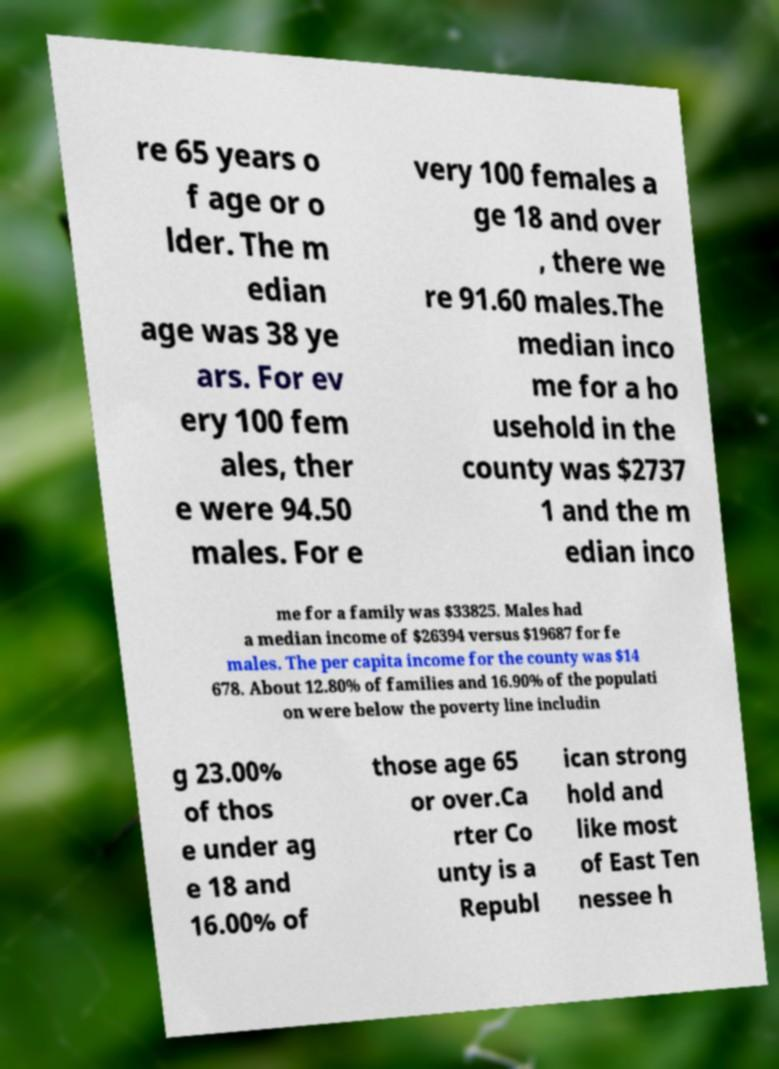Could you extract and type out the text from this image? re 65 years o f age or o lder. The m edian age was 38 ye ars. For ev ery 100 fem ales, ther e were 94.50 males. For e very 100 females a ge 18 and over , there we re 91.60 males.The median inco me for a ho usehold in the county was $2737 1 and the m edian inco me for a family was $33825. Males had a median income of $26394 versus $19687 for fe males. The per capita income for the county was $14 678. About 12.80% of families and 16.90% of the populati on were below the poverty line includin g 23.00% of thos e under ag e 18 and 16.00% of those age 65 or over.Ca rter Co unty is a Republ ican strong hold and like most of East Ten nessee h 